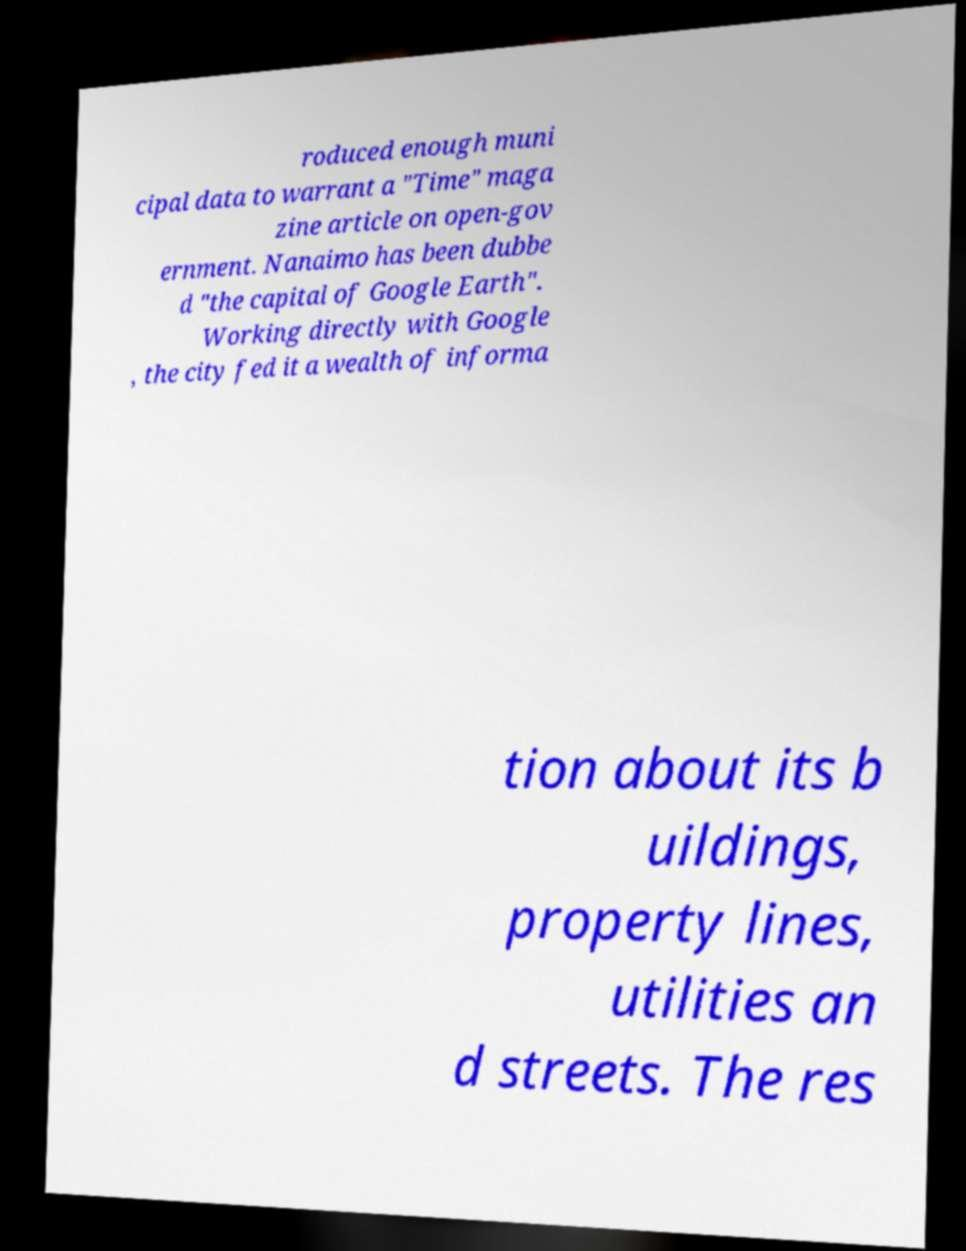Could you assist in decoding the text presented in this image and type it out clearly? roduced enough muni cipal data to warrant a "Time" maga zine article on open-gov ernment. Nanaimo has been dubbe d "the capital of Google Earth". Working directly with Google , the city fed it a wealth of informa tion about its b uildings, property lines, utilities an d streets. The res 